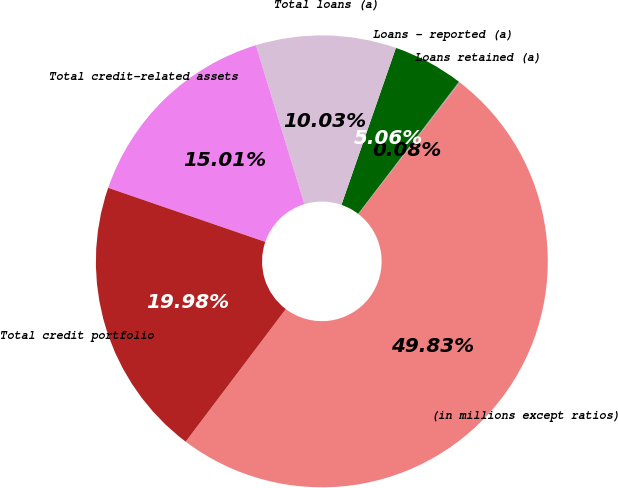Convert chart to OTSL. <chart><loc_0><loc_0><loc_500><loc_500><pie_chart><fcel>(in millions except ratios)<fcel>Loans retained (a)<fcel>Loans - reported (a)<fcel>Total loans (a)<fcel>Total credit-related assets<fcel>Total credit portfolio<nl><fcel>49.83%<fcel>0.08%<fcel>5.06%<fcel>10.03%<fcel>15.01%<fcel>19.98%<nl></chart> 